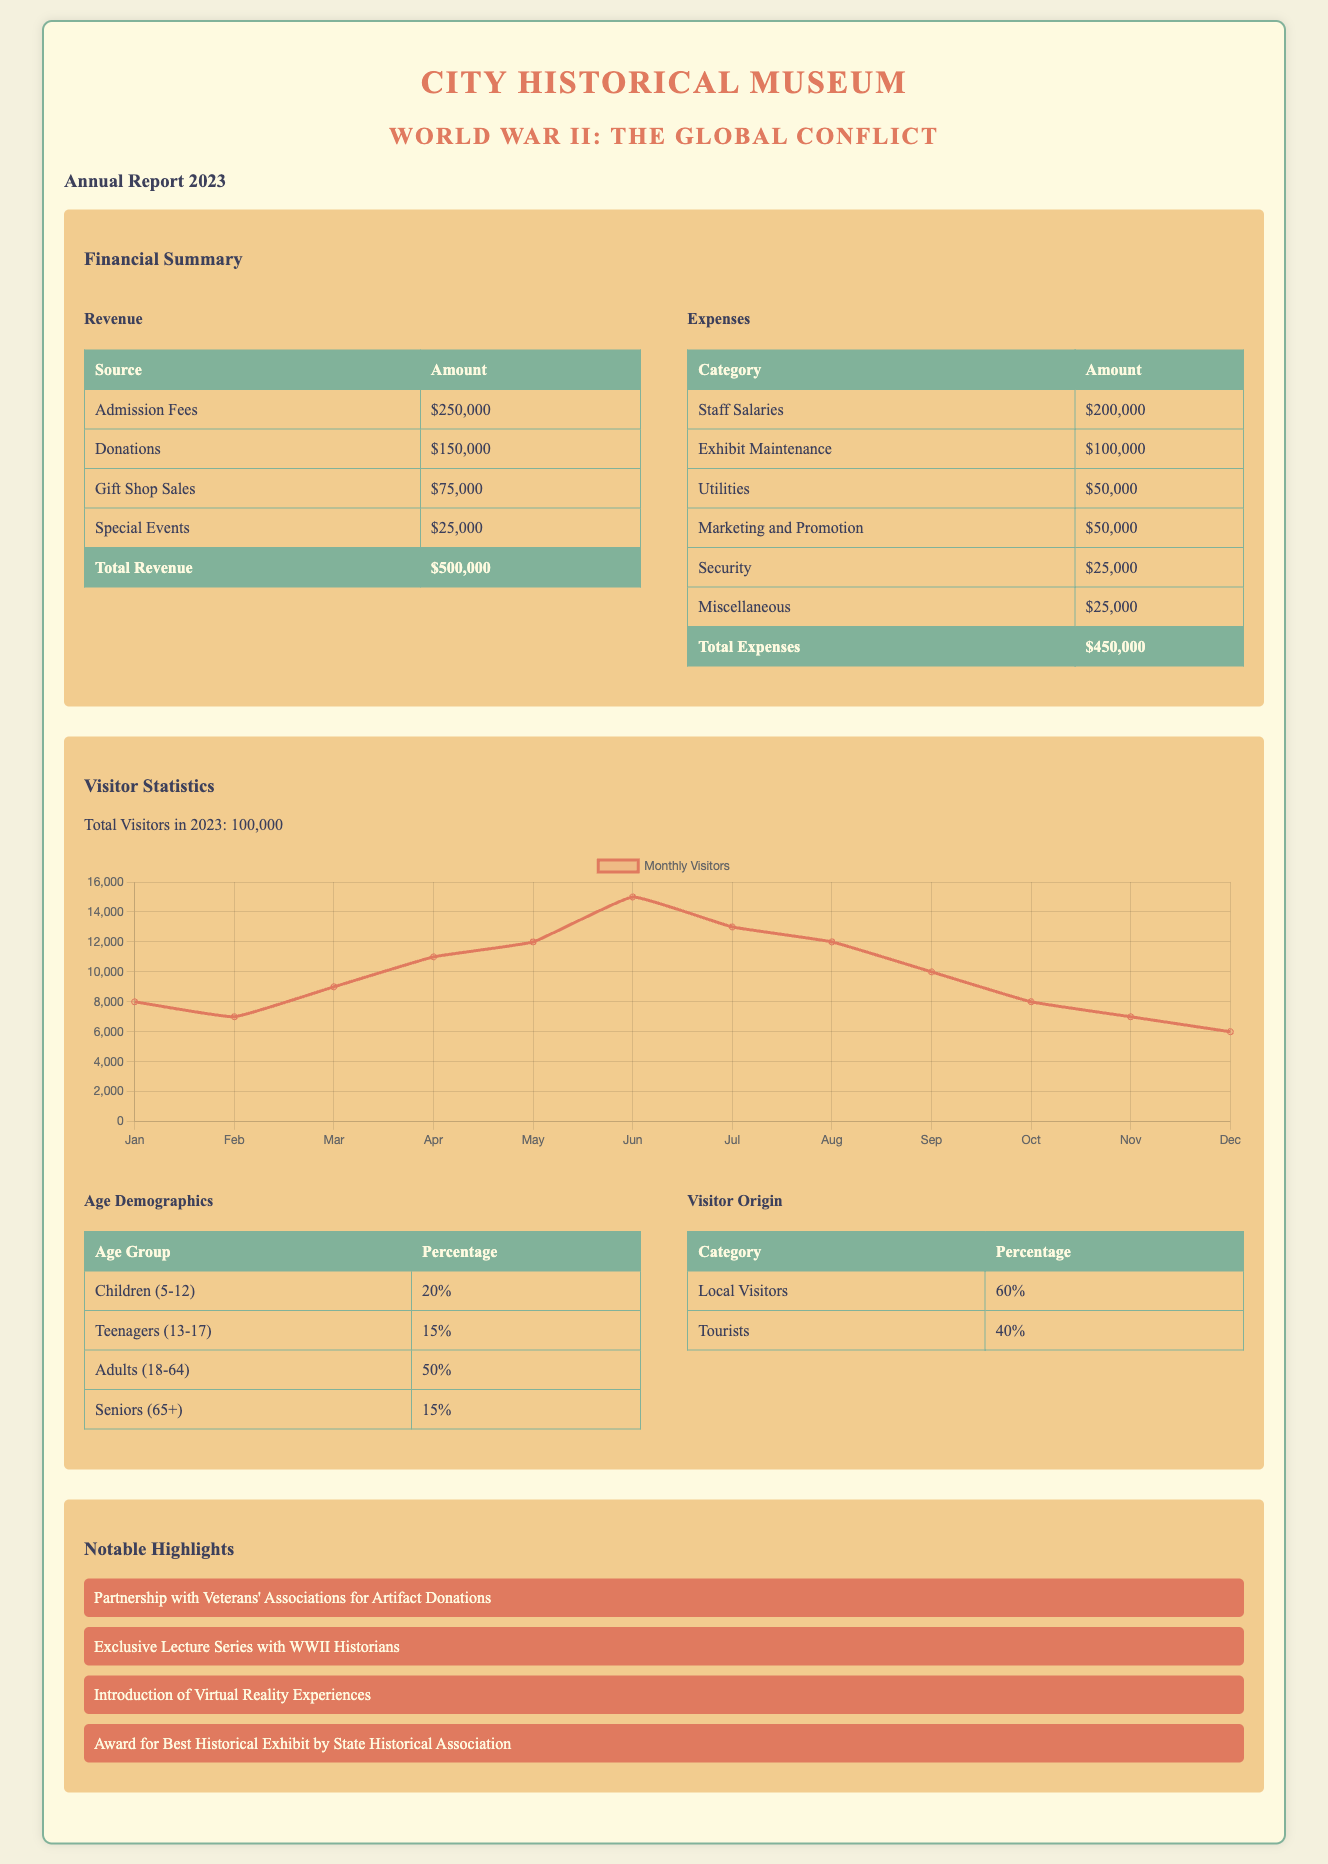What is the total revenue? The total revenue is calculated by adding all the revenue sources listed in the document: Admission Fees, Donations, Gift Shop Sales, and Special Events.
Answer: $500,000 What is the largest revenue source? The largest revenue source can be found from the revenue table in the document, which lists Admission Fees as the highest entry.
Answer: Admission Fees How much did the museum spend on staff salaries? The expenses table in the document indicates that the amount spent on staff salaries is one of the highest entries listed.
Answer: $200,000 What is the total number of visitors in 2023? The total number of visitors for the year is explicitly stated in the Visitor Statistics section of the document.
Answer: 100,000 What percentage of visitors were local? The Visitor Origin table shows the percentage of local visitors mentioned in the document, providing direct data on this aspect.
Answer: 60% What was the total amount spent on exhibit maintenance? The expenses section lists the specific amount allocated for exhibit maintenance, which reflects only that one category.
Answer: $100,000 What notable highlight involves Veterans' Associations? The notable highlight section references a specific partnership that involves Veterans' Associations for a particular activity.
Answer: Partnership with Veterans' Associations for Artifact Donations What was the award received by the museum? This award is noted in the notable highlights, showcasing recognition for the museum's efforts in a specific area.
Answer: Award for Best Historical Exhibit by State Historical Association What was the highest number of monthly visitors recorded? The monthly visitor data chart presented in the document contains the highest data point for a particular month, from which this number can be derived.
Answer: 15,000 